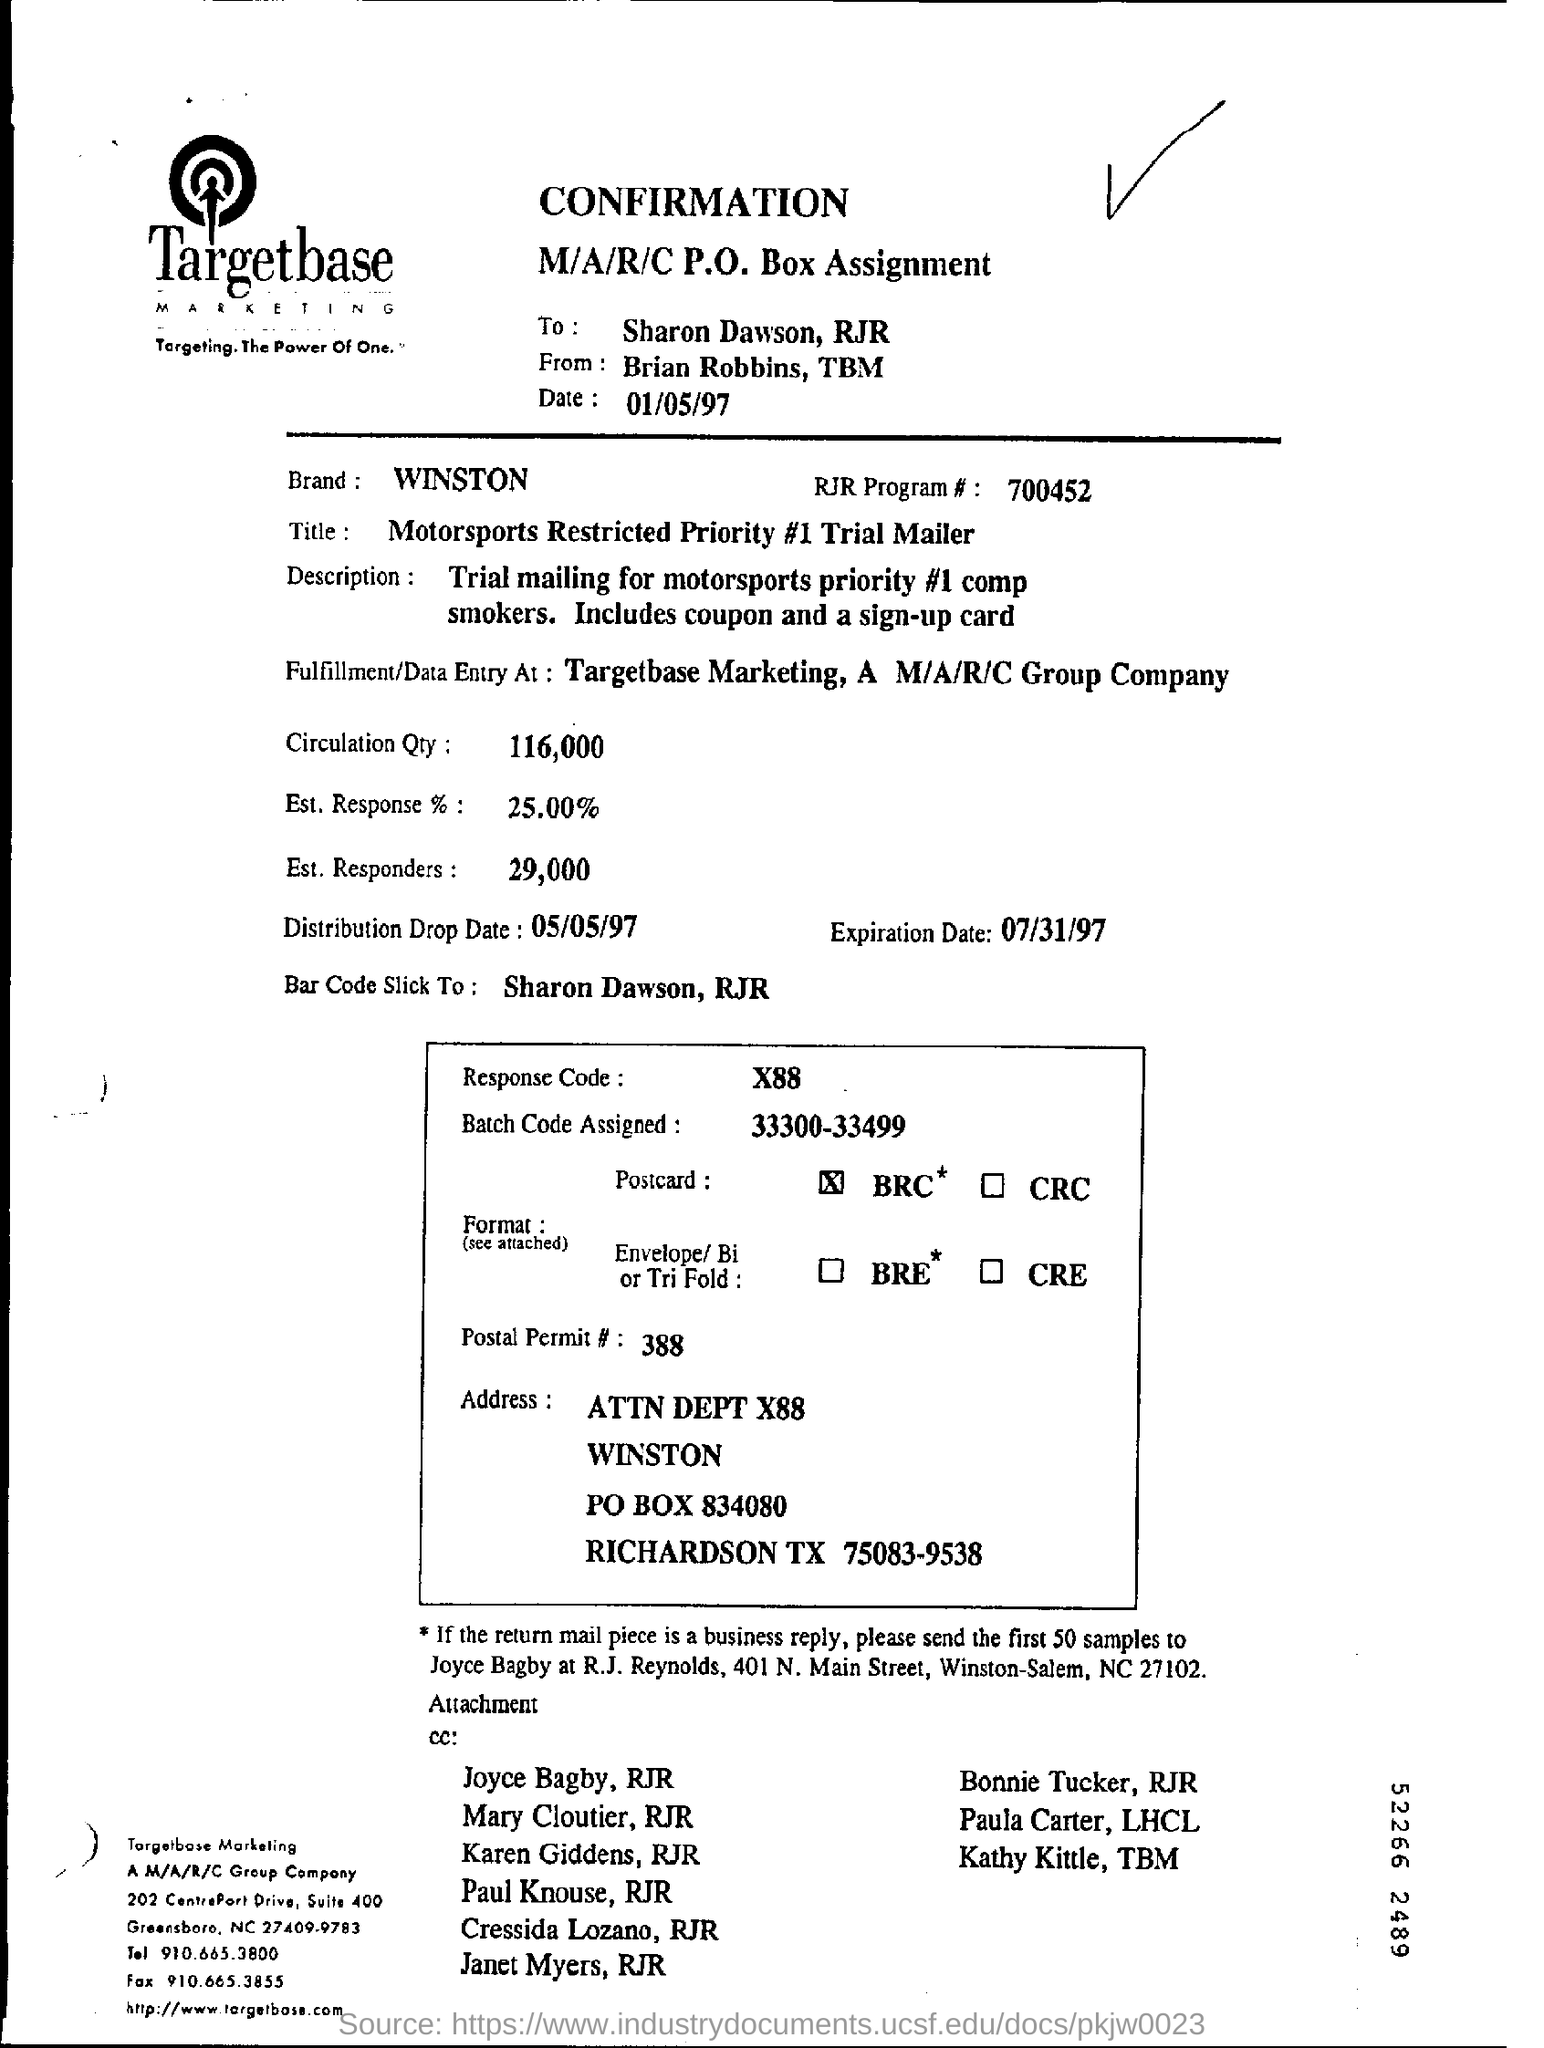What is the RJR Program# mentioned in the form?
Offer a terse response. 700452. Who is the recipient ?
Give a very brief answer. Sharon Dawson, RJR. What is the date mentioned in the top of the document ?
Provide a succinct answer. 01/05/97. What is the Brand Name ?
Your answer should be compact. WINSTON. What is the Distribution Drop Date ?
Make the answer very short. 05/05/97. What is the RJR Program Number ?
Your response must be concise. 700452. What is the Expiration Date ?
Offer a terse response. 07/31/97. What is written in the Response Code Field ?
Make the answer very short. X88. What is Postal Permit Number ?
Your answer should be compact. 388. What is the P.O Box Number ?
Keep it short and to the point. 834080. 